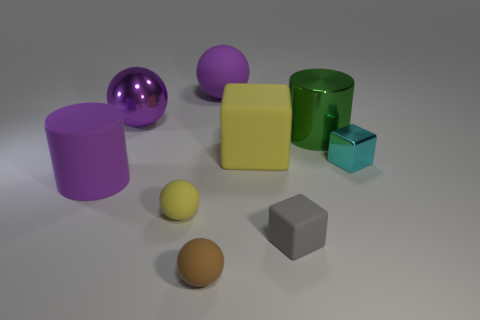Subtract all cyan blocks. How many purple spheres are left? 2 Subtract all yellow cubes. How many cubes are left? 2 Subtract 1 spheres. How many spheres are left? 3 Subtract all yellow balls. How many balls are left? 3 Subtract all cylinders. How many objects are left? 7 Subtract all cyan balls. Subtract all green cylinders. How many balls are left? 4 Subtract all large purple shiny objects. Subtract all large yellow objects. How many objects are left? 7 Add 4 tiny yellow objects. How many tiny yellow objects are left? 5 Add 1 tiny gray matte cubes. How many tiny gray matte cubes exist? 2 Subtract 1 brown balls. How many objects are left? 8 